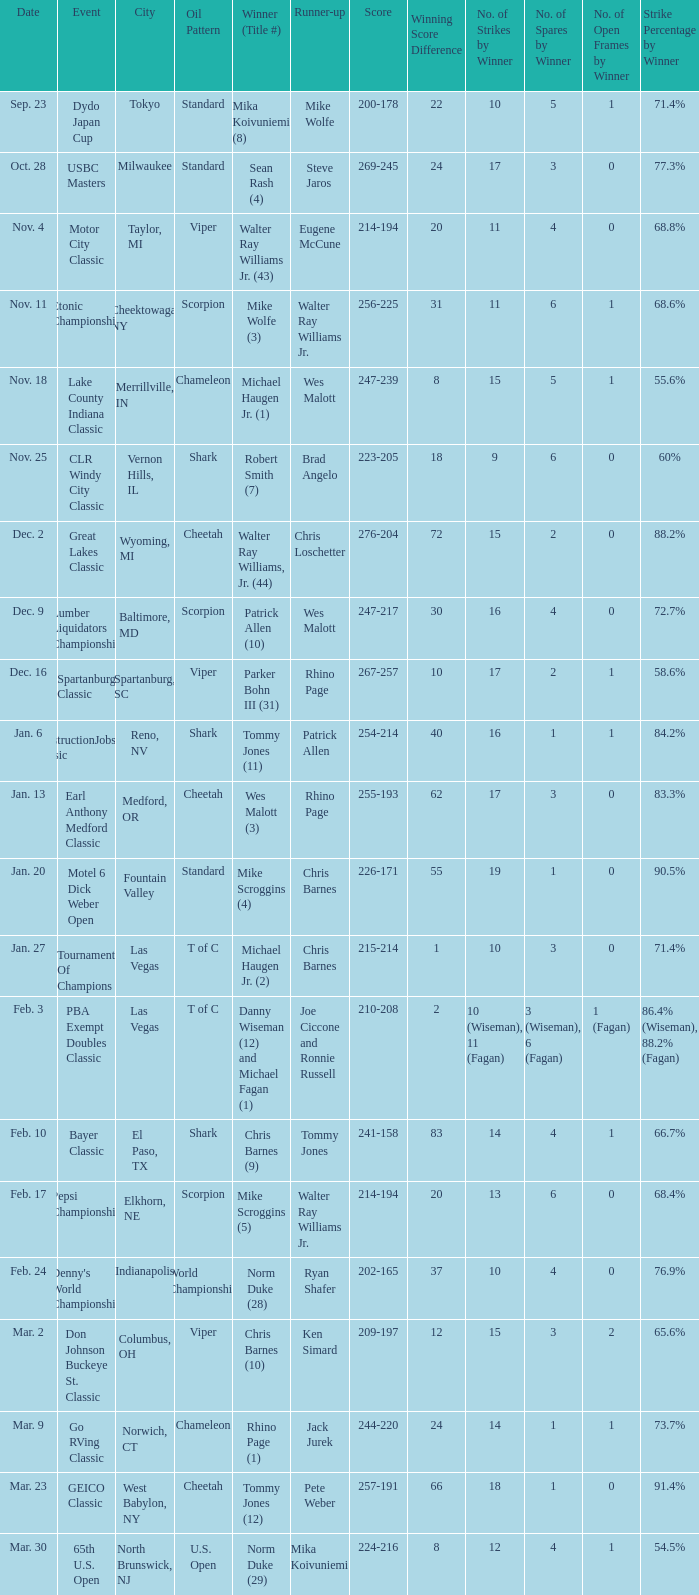Which Score has an Event of constructionjobs.com classic? 254-214. 